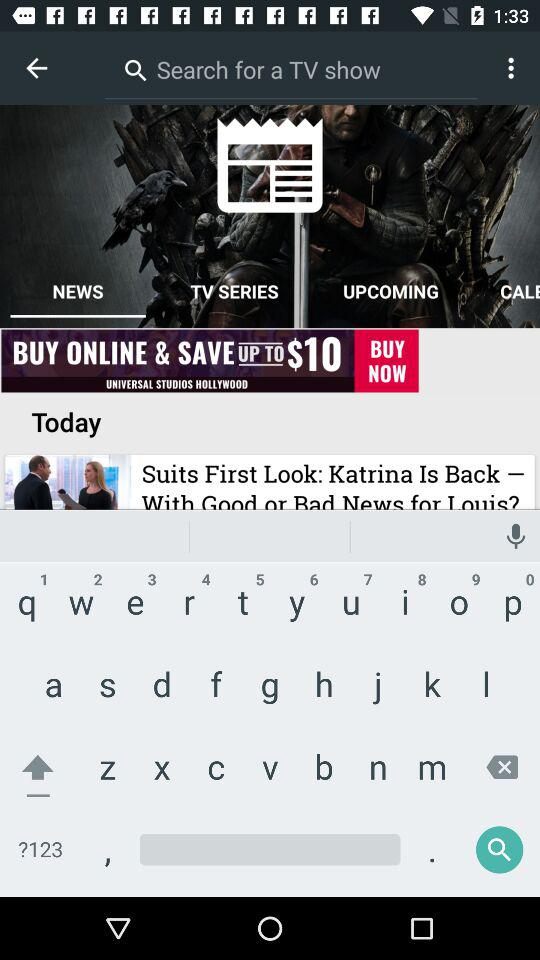What are the names of the television series show? The names of the television series shows are "The Flash (2014)", "The Walking Dead", "The Vampire Diaries", "Arrow", "Game of Thrones" and "Supernatural". 